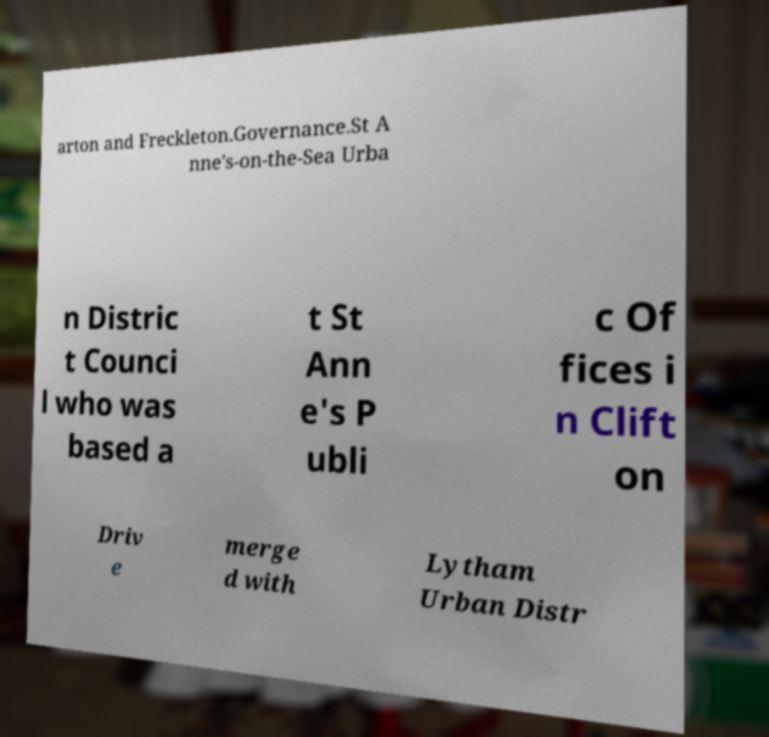Could you extract and type out the text from this image? arton and Freckleton.Governance.St A nne's-on-the-Sea Urba n Distric t Counci l who was based a t St Ann e's P ubli c Of fices i n Clift on Driv e merge d with Lytham Urban Distr 